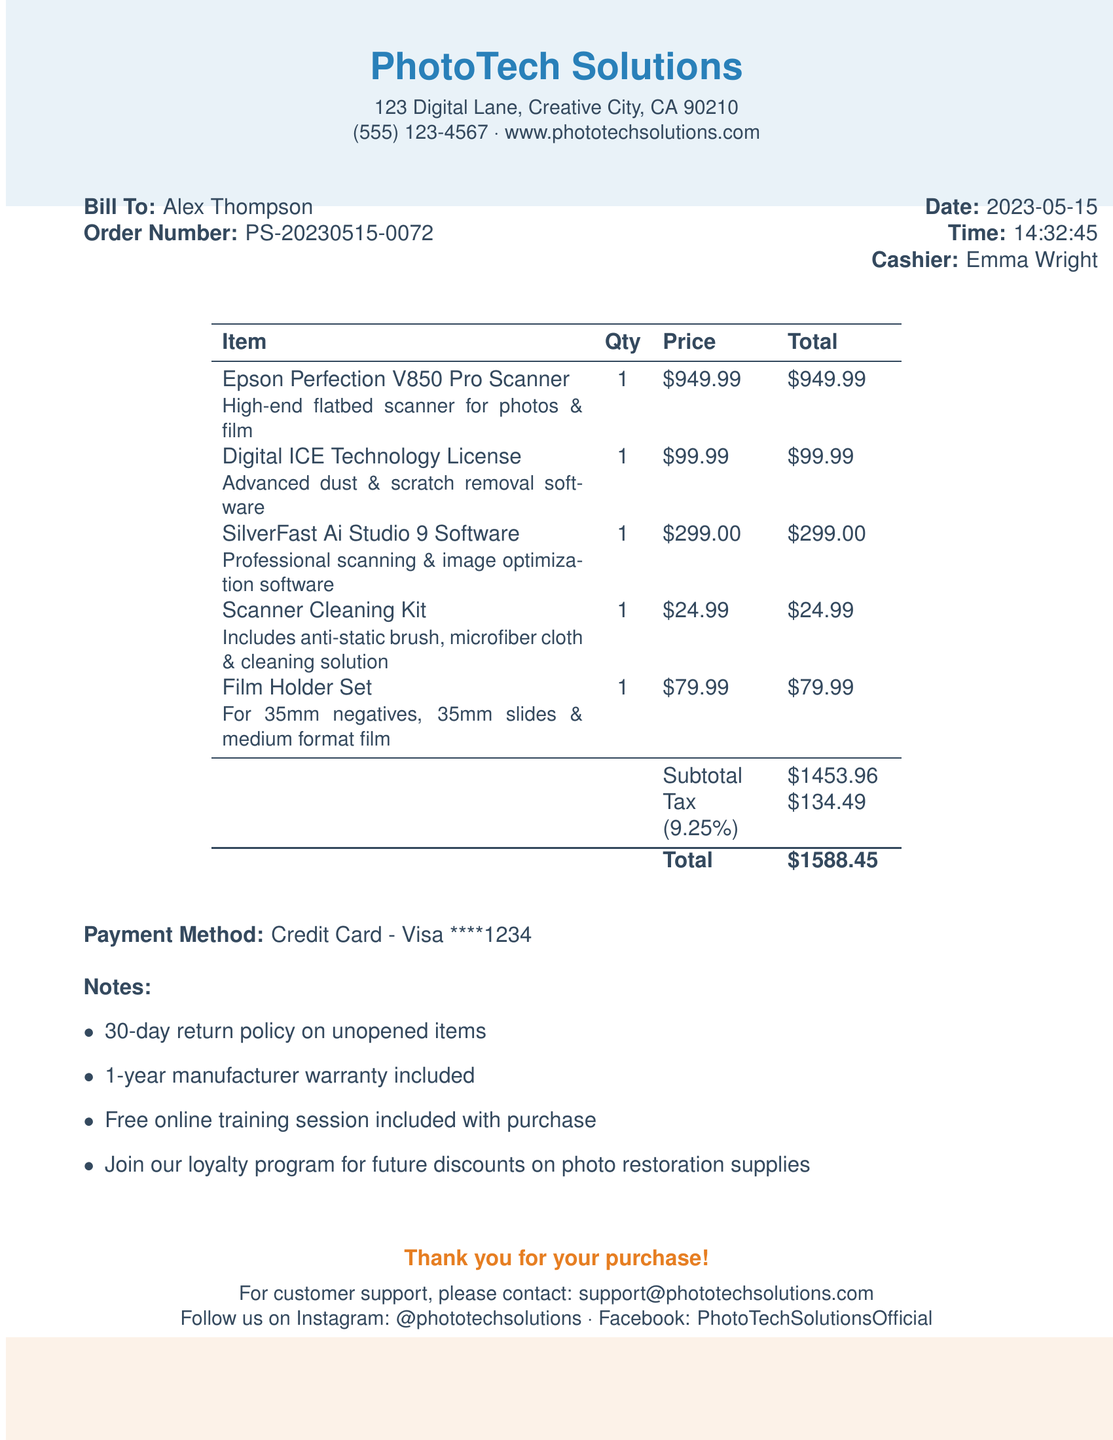What is the name of the store? The store name is listed at the top of the document, identified as PhotoTech Solutions.
Answer: PhotoTech Solutions Who was the cashier for the transaction? The cashier's name is provided alongside the date and time of the transaction.
Answer: Emma Wright What is the date of the purchase? The document specifies the date prominently, indicating when the transaction occurred.
Answer: 2023-05-15 What is the total amount paid? The total amount is calculated as the subtotal plus tax, shown at the bottom of the receipt.
Answer: 1588.45 How many items were purchased? Each item is listed individually in the receipt, with quantities specified for each.
Answer: 5 What is included with the purchase? Notes at the end of the document outline additional benefits that come with the purchase.
Answer: Free online training session What type of payment was used? The payment method is specified as part of the transaction details in the document.
Answer: Credit Card - Visa ****1234 What does the Digital ICE Technology License do? The description for this item provides insight into its functionality related to photo restoration.
Answer: Advanced dust & scratch removal software What is the order number associated with this transaction? The order number is listed for reference to identify this specific transaction.
Answer: PS-20230515-0072 